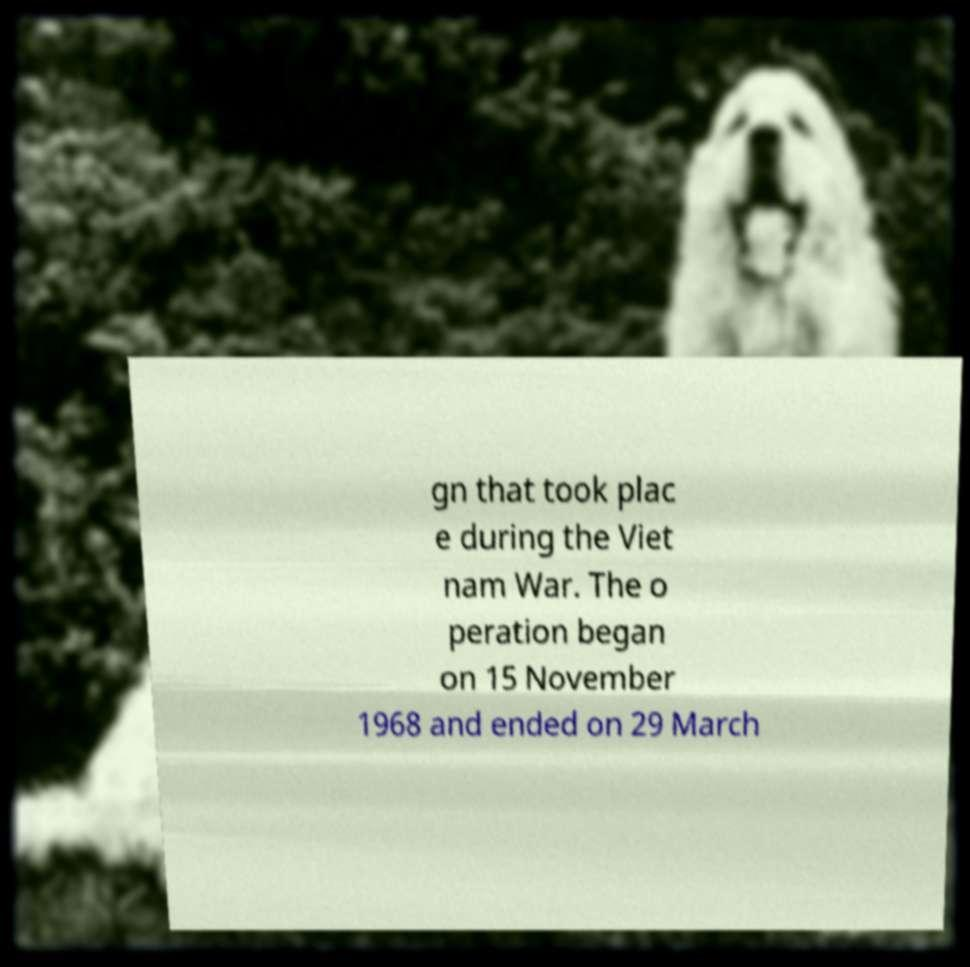Could you extract and type out the text from this image? gn that took plac e during the Viet nam War. The o peration began on 15 November 1968 and ended on 29 March 